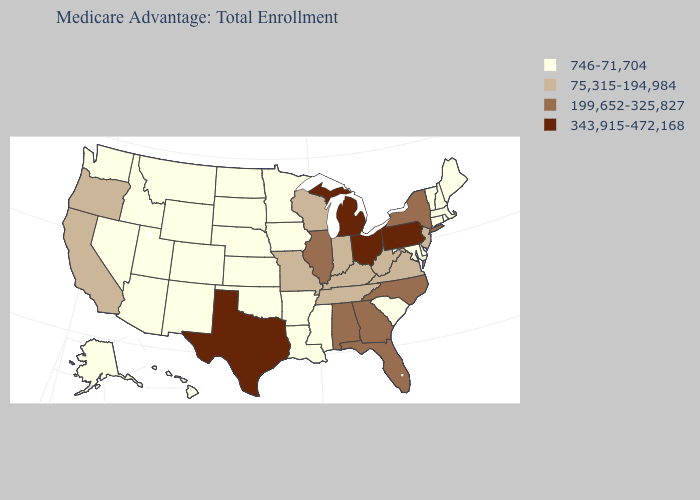Which states have the lowest value in the West?
Concise answer only. Alaska, Arizona, Colorado, Hawaii, Idaho, Montana, Nevada, New Mexico, Utah, Washington, Wyoming. Does Michigan have the highest value in the USA?
Write a very short answer. Yes. Does Idaho have a lower value than Michigan?
Write a very short answer. Yes. Does the first symbol in the legend represent the smallest category?
Keep it brief. Yes. What is the value of South Carolina?
Answer briefly. 746-71,704. Among the states that border Connecticut , does Massachusetts have the lowest value?
Keep it brief. Yes. Does Texas have the highest value in the USA?
Be succinct. Yes. What is the lowest value in the USA?
Write a very short answer. 746-71,704. What is the value of New York?
Write a very short answer. 199,652-325,827. What is the highest value in the MidWest ?
Concise answer only. 343,915-472,168. What is the value of Alaska?
Answer briefly. 746-71,704. Among the states that border South Carolina , which have the highest value?
Keep it brief. Georgia, North Carolina. Which states have the highest value in the USA?
Be succinct. Michigan, Ohio, Pennsylvania, Texas. 